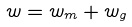<formula> <loc_0><loc_0><loc_500><loc_500>w = w _ { m } + w _ { g }</formula> 